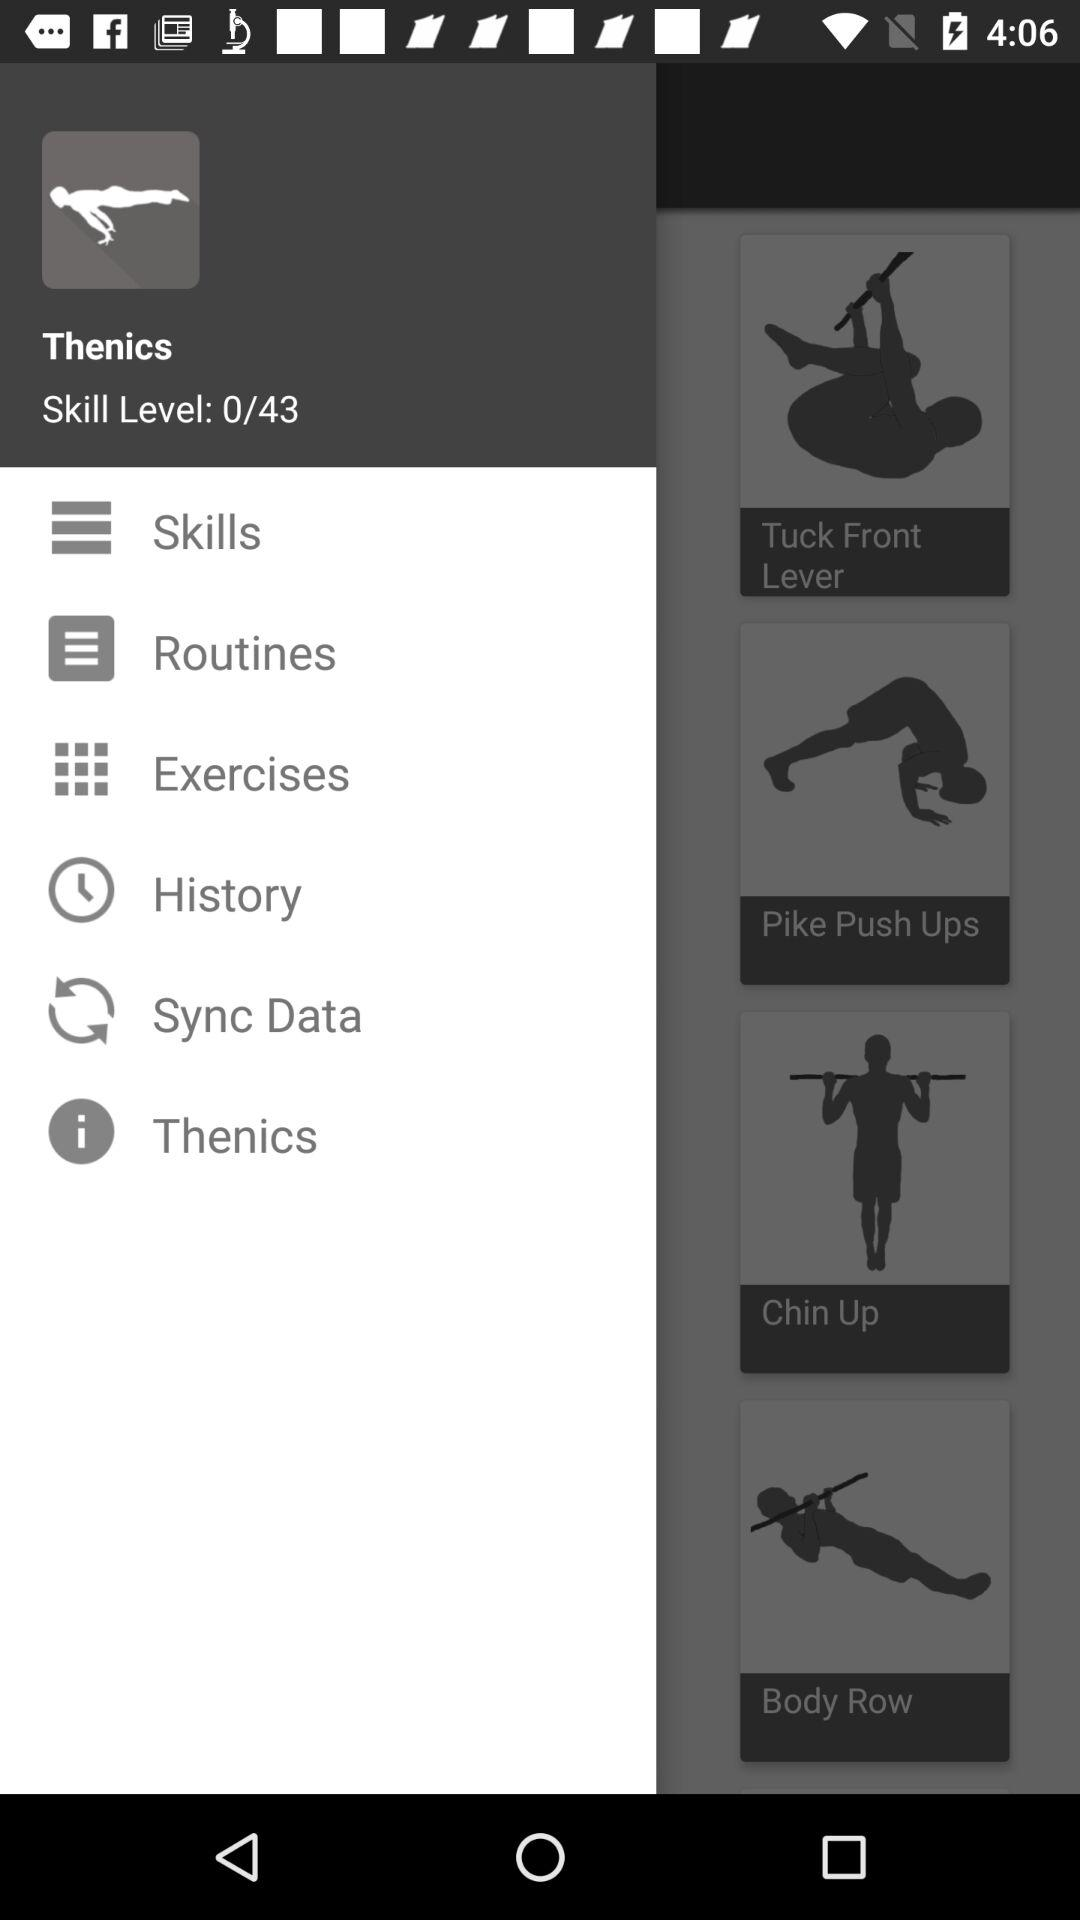How many total skill levels are there? There are a total of 43 skill levels. 